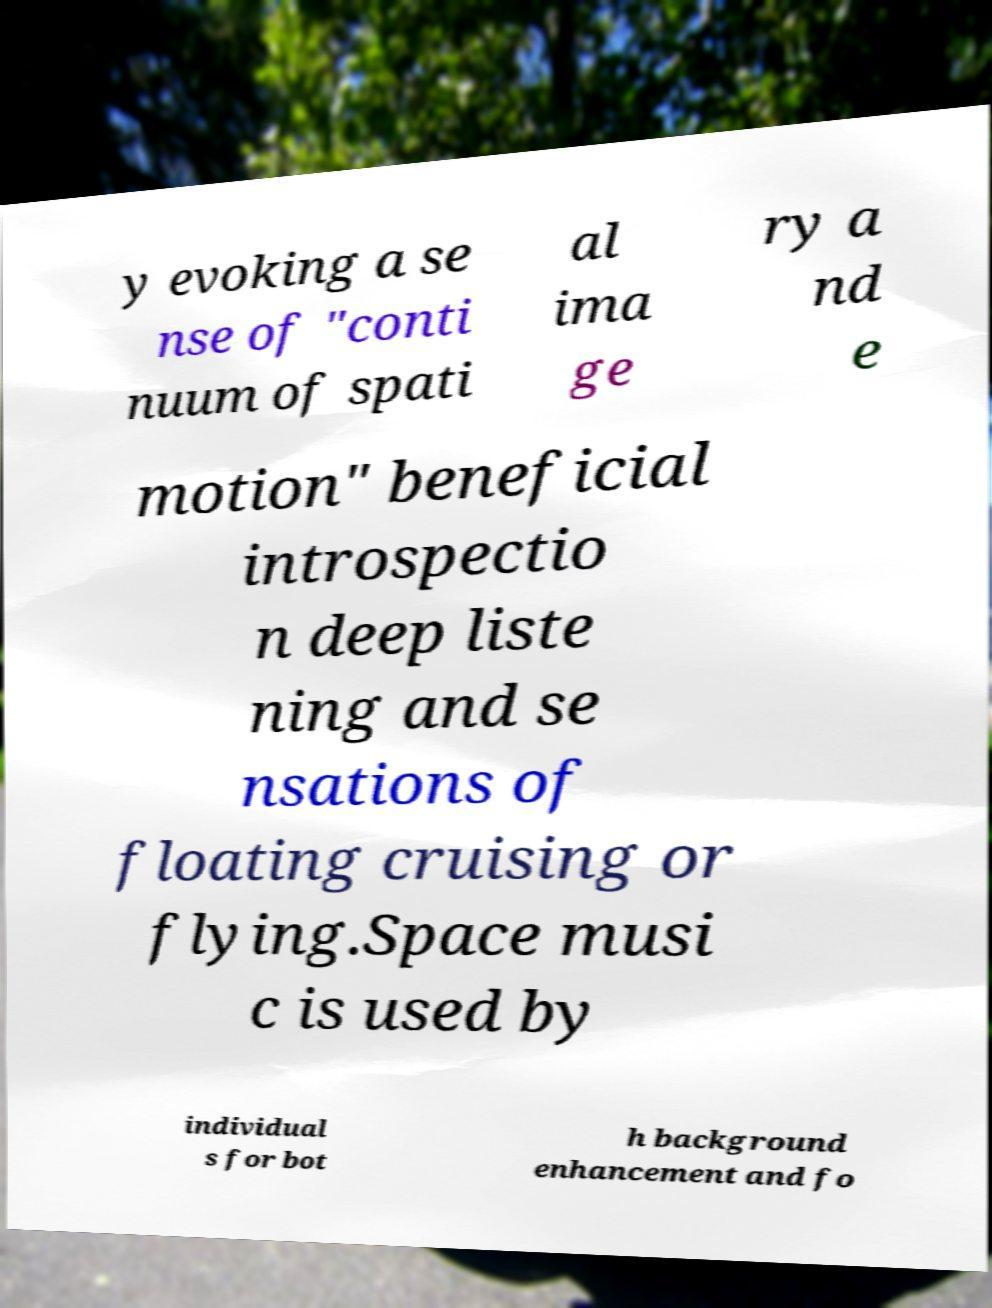Can you read and provide the text displayed in the image?This photo seems to have some interesting text. Can you extract and type it out for me? y evoking a se nse of "conti nuum of spati al ima ge ry a nd e motion" beneficial introspectio n deep liste ning and se nsations of floating cruising or flying.Space musi c is used by individual s for bot h background enhancement and fo 